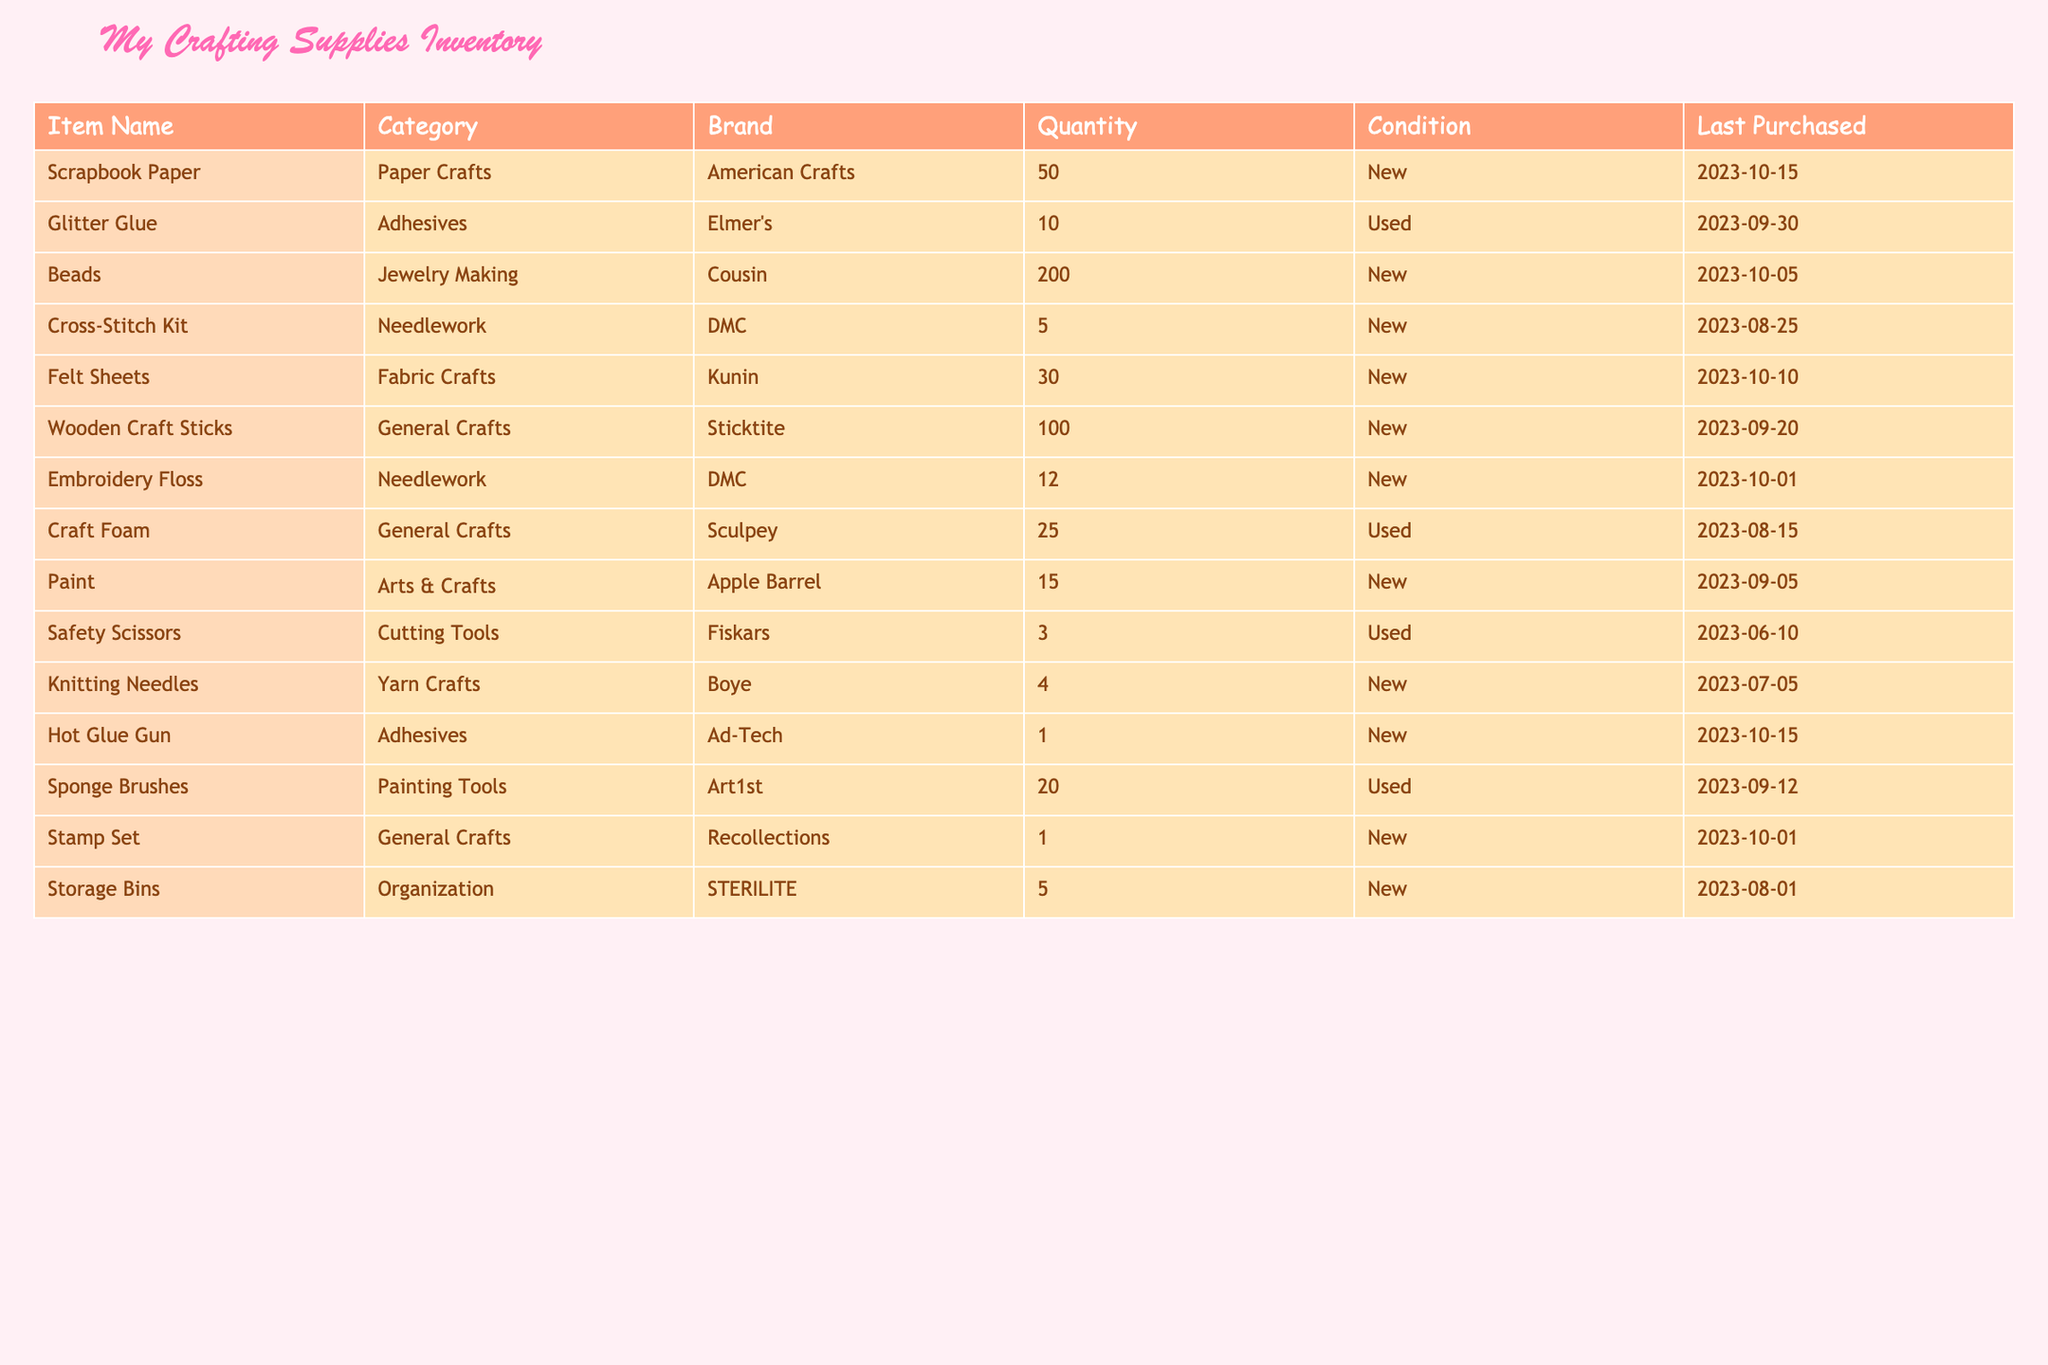What is the quantity of Scrapbook Paper in the inventory? The table lists Scrapbook Paper under the "Item Name" column, where the corresponding "Quantity" is provided. By directly looking at that row, we see that the quantity is 50.
Answer: 50 How many types of Needlework supplies are included in the inventory? The table shows two items in the Needlework category: Cross-Stitch Kit and Embroidery Floss. Therefore, by counting these two rows, the total number of types of Needlework supplies is 2.
Answer: 2 Is there any item in Used condition that has a Quantity greater than 10? To determine this, we examine the “Condition” and “Quantity” columns for any used items. The Glitter Glue (quantity 10) and Craft Foam (quantity 25) fall into this category, but only Craft Foam exceeds 10 in quantity. Therefore, the answer is yes.
Answer: Yes What is the total quantity of General Crafts supplies available? General Crafts includes three items: Wooden Craft Sticks (100), Craft Foam (25), and Stamp Set (1). By summing these quantities (100 + 25 + 1), we find the total quantity of General Crafts supplies is 126.
Answer: 126 Are there any items from the brand DMC in the inventory? By scanning the "Brand" column, we find two items listed under the DMC brand: Cross-Stitch Kit and Embroidery Floss. Since there are items associated with DMC, the answer is yes.
Answer: Yes What is the difference in quantity between the highest and lowest quantities of items listed? Looking through the "Quantity" column, the highest quantity is 200 (Beads) and the lowest is 1 (Stamp Set). Therefore, the difference is 200 - 1 = 199.
Answer: 199 How many supplies are listed as New? We can count the items with the condition marked as New. Analyzing the table, we see that there are 8 supplies listed with New condition.
Answer: 8 What is the average quantity of all items in the inventory? To find the average, we first sum up all the quantities: 50 + 10 + 200 + 5 + 30 + 100 + 12 + 25 + 15 + 3 + 4 + 1 + 20 + 1 + 5 = 455. Since there are 15 items, we divide the total by 15, resulting in an average of 455 / 15 = 30.33.
Answer: 30.33 How many items have a Last Purchased date in October 2023? By examining the "Last Purchased" column, we identify the items purchased in October: Scrapbook Paper (10/15), Beads (10/05), Embroidery Floss (10/01), Hot Glue Gun (10/15), and Stamp Set (10/01). This results in a total of 5 items purchased in October.
Answer: 5 